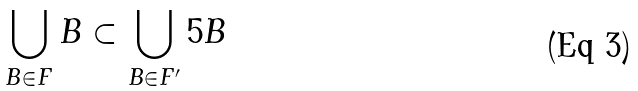Convert formula to latex. <formula><loc_0><loc_0><loc_500><loc_500>\bigcup _ { B \in F } B \subset \bigcup _ { B \in F ^ { \prime } } 5 B</formula> 